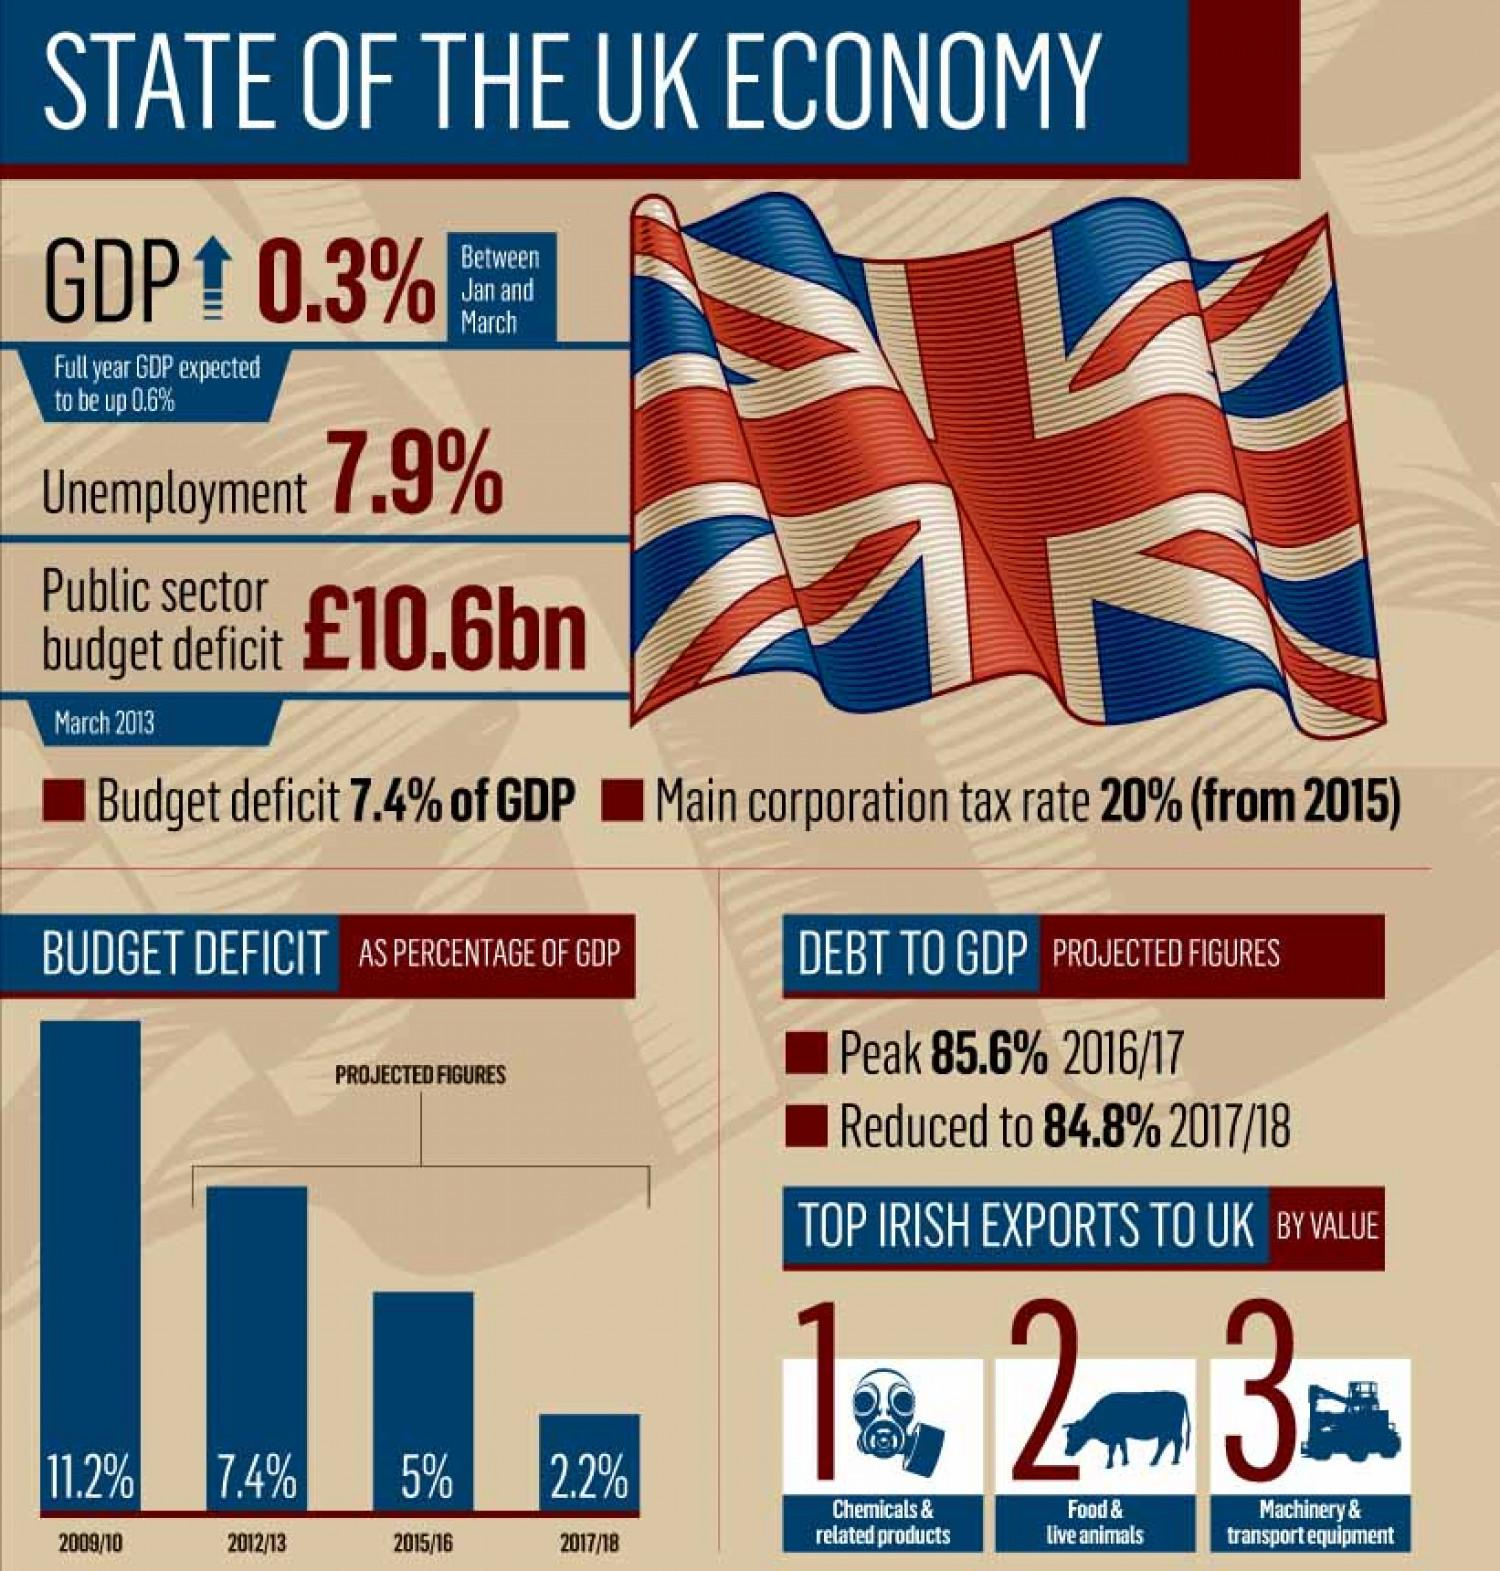Mention a couple of crucial points in this snapshot. The third highest GDP of the United Kingdom was observed in the year 2015/16. In 2012/13, the second highest GDP of the United Kingdom was observed. The Gross Domestic Product (GDP) percentage of the United Kingdom decreased by 0.8% from 2016 to 2018. The second most valuable Irish export to the UK is food and live animals. The third most valuable Irish export to the UK is machinery and transport equipment. 